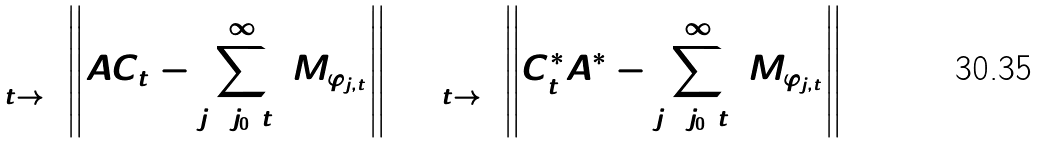<formula> <loc_0><loc_0><loc_500><loc_500>\lim _ { t \to 0 } \left \| A C _ { t } - \sum _ { j = j _ { 0 } ( t ) } ^ { \infty } M _ { \varphi _ { j , t } } \right \| = \lim _ { t \to 0 } \left \| C _ { t } ^ { \ast } A ^ { \ast } - \sum _ { j = j _ { 0 } ( t ) } ^ { \infty } M _ { \varphi _ { j , t } } \right \| = 0</formula> 